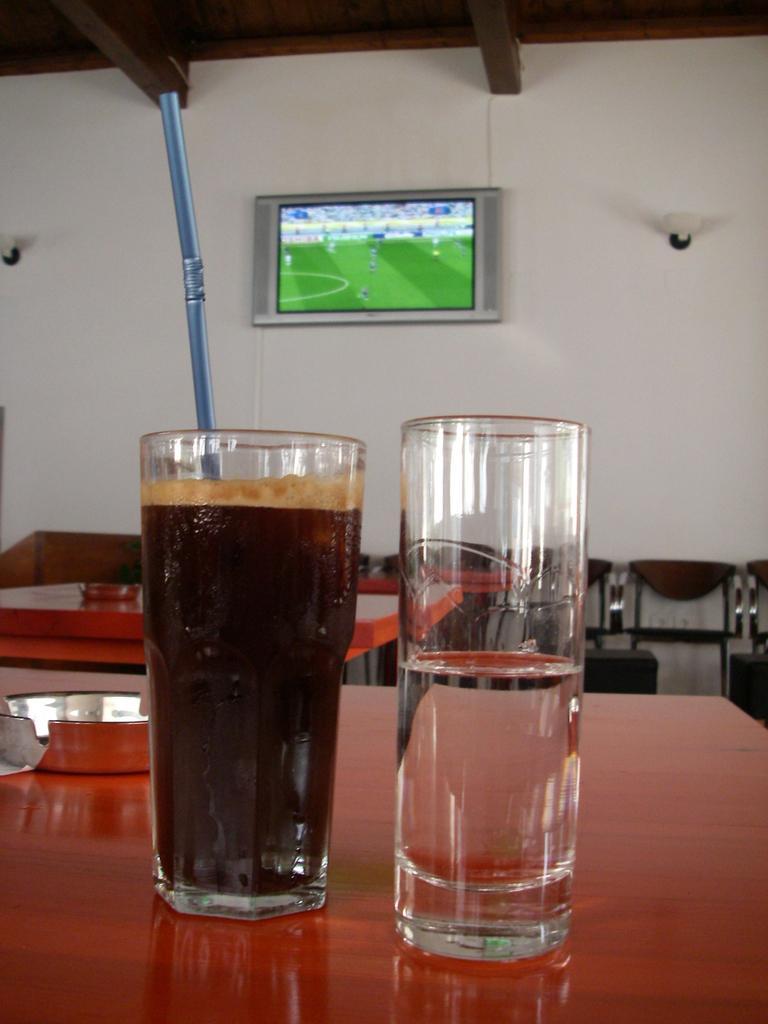Can you describe this image briefly? In this image I can see the table and on the table I can see two glasses with liquids in them. I can see a blue colored straw in the glass. In the background I can see a table, few chairs, the wall, a television to the wall and the brown colored ceiling. 